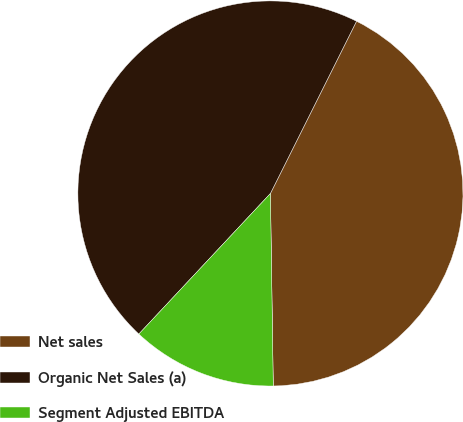Convert chart to OTSL. <chart><loc_0><loc_0><loc_500><loc_500><pie_chart><fcel>Net sales<fcel>Organic Net Sales (a)<fcel>Segment Adjusted EBITDA<nl><fcel>42.39%<fcel>45.41%<fcel>12.21%<nl></chart> 